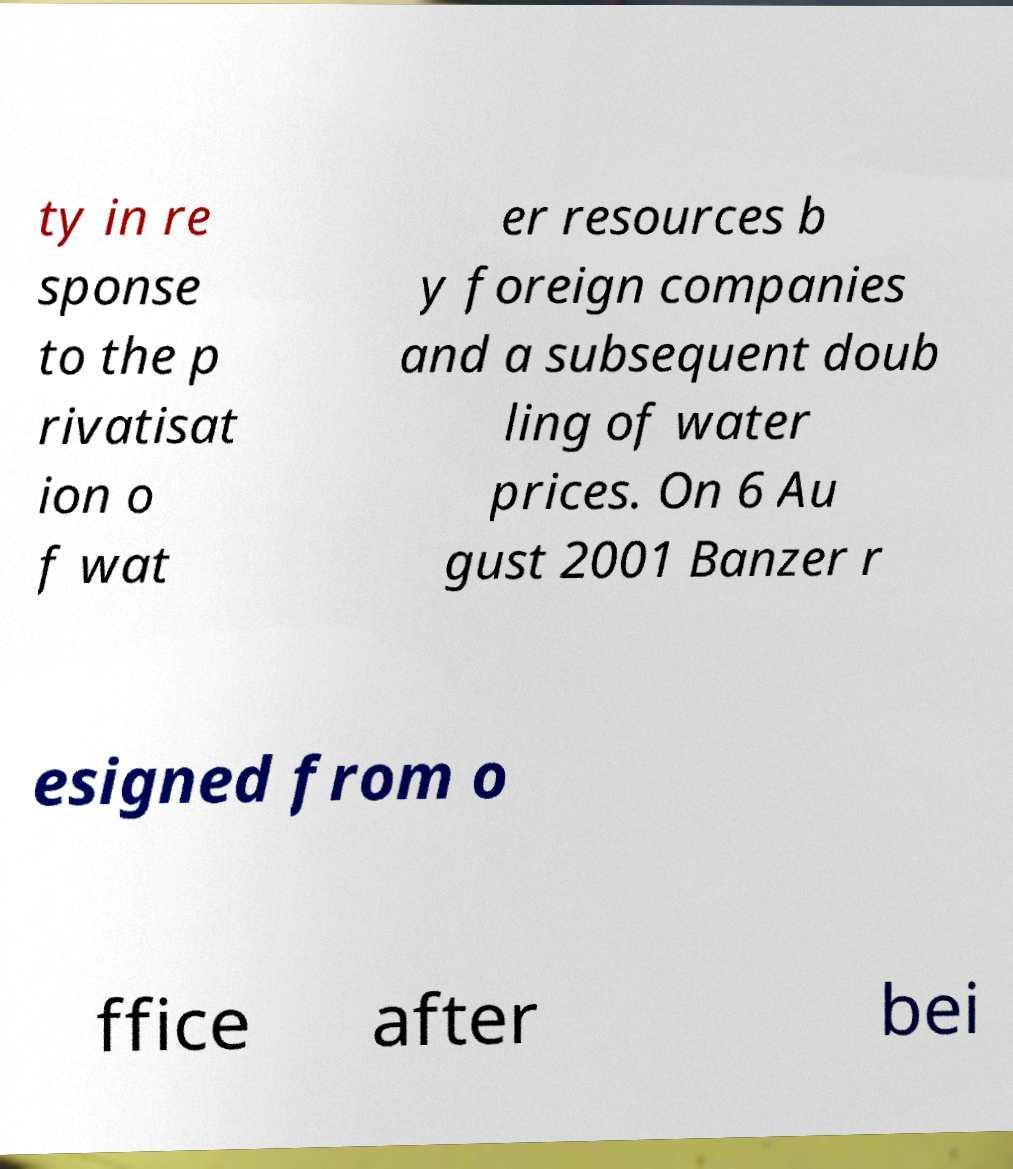For documentation purposes, I need the text within this image transcribed. Could you provide that? ty in re sponse to the p rivatisat ion o f wat er resources b y foreign companies and a subsequent doub ling of water prices. On 6 Au gust 2001 Banzer r esigned from o ffice after bei 